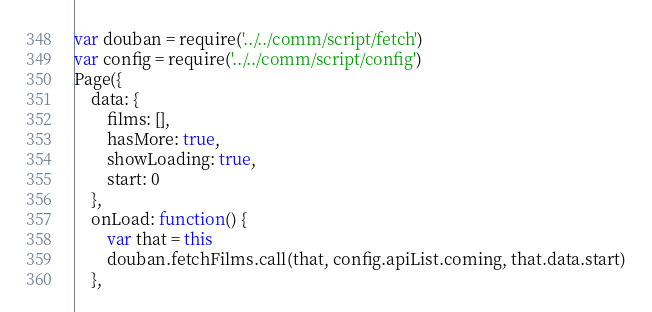Convert code to text. <code><loc_0><loc_0><loc_500><loc_500><_JavaScript_>var douban = require('../../comm/script/fetch')
var config = require('../../comm/script/config')
Page({
	data: {
		films: [],
		hasMore: true,
		showLoading: true,
		start: 0
	},
	onLoad: function() {
		var that = this
		douban.fetchFilms.call(that, config.apiList.coming, that.data.start)
	},</code> 